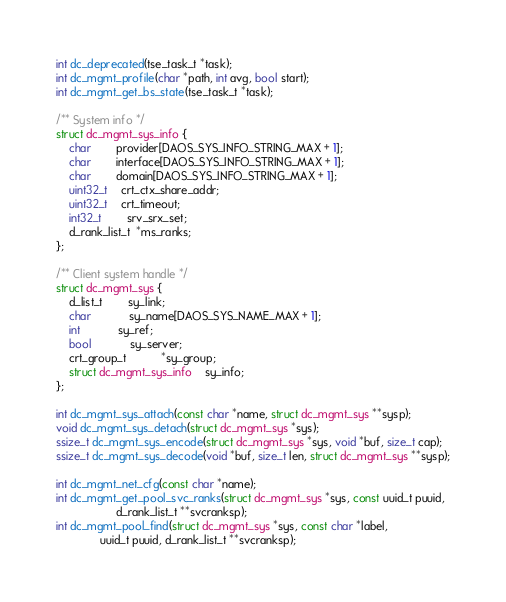<code> <loc_0><loc_0><loc_500><loc_500><_C_>int dc_deprecated(tse_task_t *task);
int dc_mgmt_profile(char *path, int avg, bool start);
int dc_mgmt_get_bs_state(tse_task_t *task);

/** System info */
struct dc_mgmt_sys_info {
	char		provider[DAOS_SYS_INFO_STRING_MAX + 1];
	char		interface[DAOS_SYS_INFO_STRING_MAX + 1];
	char		domain[DAOS_SYS_INFO_STRING_MAX + 1];
	uint32_t	crt_ctx_share_addr;
	uint32_t	crt_timeout;
	int32_t		srv_srx_set;
	d_rank_list_t  *ms_ranks;
};

/** Client system handle */
struct dc_mgmt_sys {
	d_list_t		sy_link;
	char			sy_name[DAOS_SYS_NAME_MAX + 1];
	int			sy_ref;
	bool			sy_server;
	crt_group_t	       *sy_group;
	struct dc_mgmt_sys_info	sy_info;
};

int dc_mgmt_sys_attach(const char *name, struct dc_mgmt_sys **sysp);
void dc_mgmt_sys_detach(struct dc_mgmt_sys *sys);
ssize_t dc_mgmt_sys_encode(struct dc_mgmt_sys *sys, void *buf, size_t cap);
ssize_t dc_mgmt_sys_decode(void *buf, size_t len, struct dc_mgmt_sys **sysp);

int dc_mgmt_net_cfg(const char *name);
int dc_mgmt_get_pool_svc_ranks(struct dc_mgmt_sys *sys, const uuid_t puuid,
			       d_rank_list_t **svcranksp);
int dc_mgmt_pool_find(struct dc_mgmt_sys *sys, const char *label,
		      uuid_t puuid, d_rank_list_t **svcranksp);</code> 